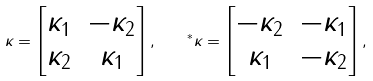Convert formula to latex. <formula><loc_0><loc_0><loc_500><loc_500>\kappa = \begin{bmatrix} \kappa _ { 1 } & - \kappa _ { 2 } \\ \kappa _ { 2 } & \kappa _ { 1 } \end{bmatrix} , \quad ^ { \ast } \kappa = \begin{bmatrix} - \kappa _ { 2 } & - \kappa _ { 1 } \\ \kappa _ { 1 } & - \kappa _ { 2 } \end{bmatrix} ,</formula> 